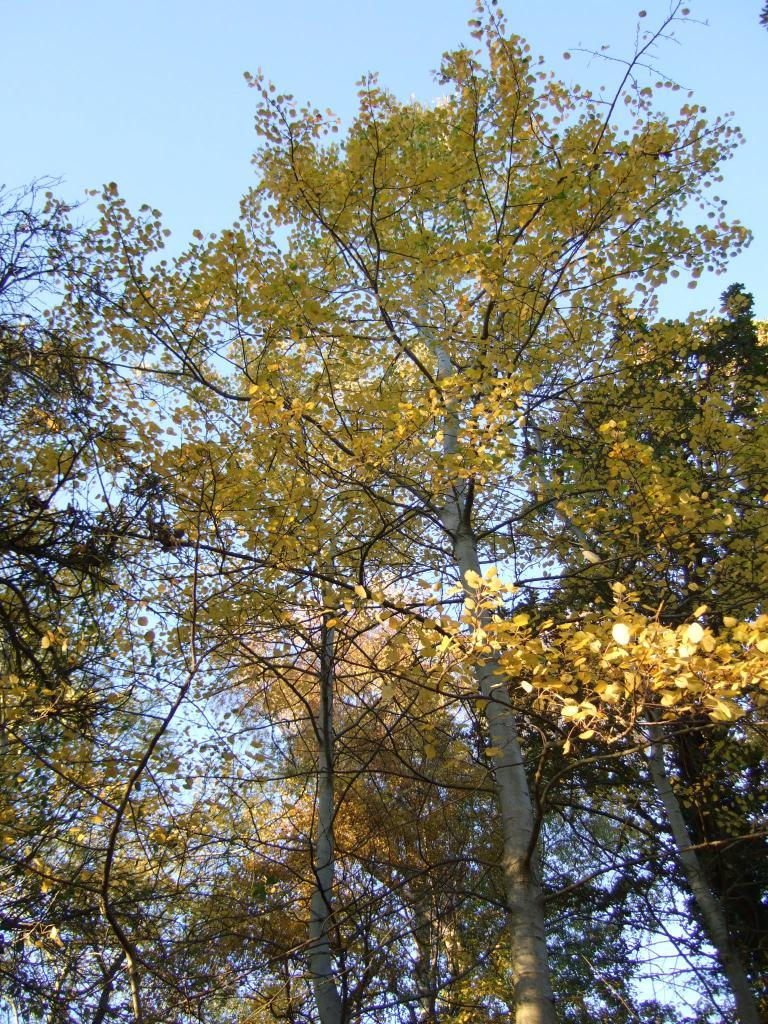What color is the tree that is visible in the image? The tree in the image is yellow. What is visible at the top of the image? The sky is visible at the top of the image. What type of guitar is the minister playing in the image? There is no minister or guitar present in the image; it only features a yellow tree and the sky. 